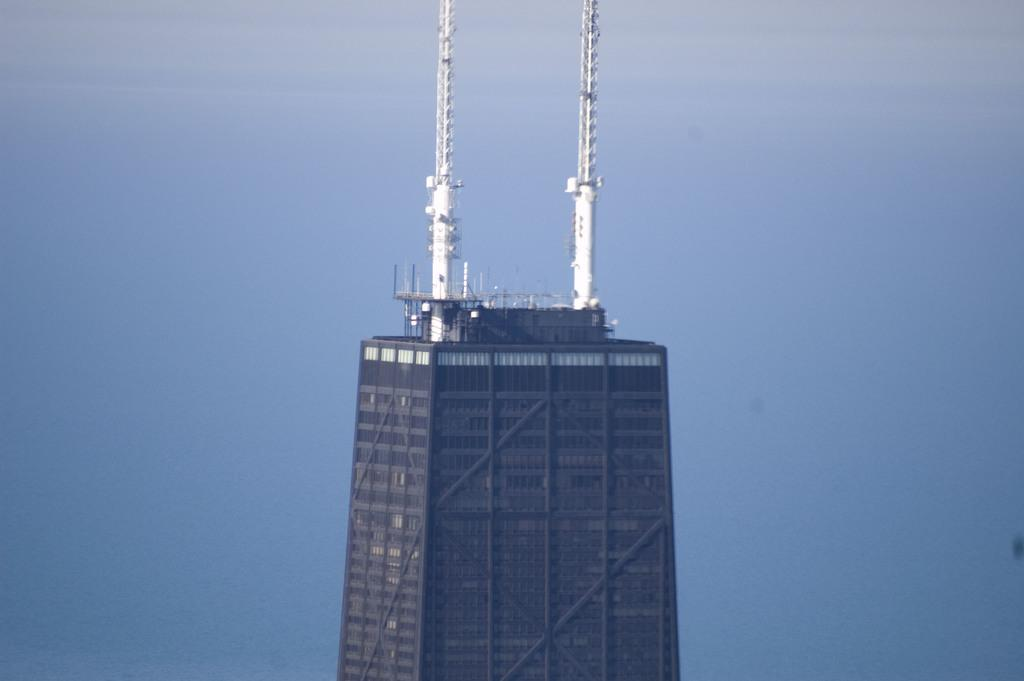What is the main structure in the image? There is a huge building in the image. What is the color of the building? The building is brown in color. Are there any distinctive features on top of the building? Yes, there are two white-colored towers on top of the building. What can be seen in the background of the image? The sky is visible in the background of the image. What type of rhythm can be heard coming from the building in the image? There is no indication of any rhythm or sound in the image, as it is a static representation of a building. 